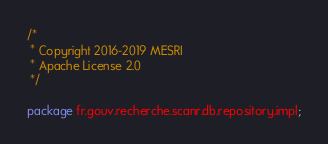<code> <loc_0><loc_0><loc_500><loc_500><_Java_>/*
 * Copyright 2016-2019 MESRI
 * Apache License 2.0
 */

package fr.gouv.recherche.scanr.db.repository.impl;
</code> 